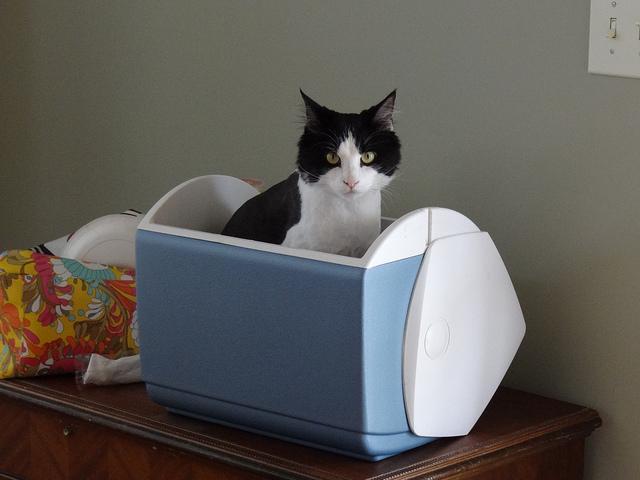What is this cat sitting in?
Keep it brief. Cooler. Is the cat sitting in a pet carrier?
Give a very brief answer. No. What color is the cat?
Keep it brief. Black and white. Is the cat sleeping?
Quick response, please. No. 